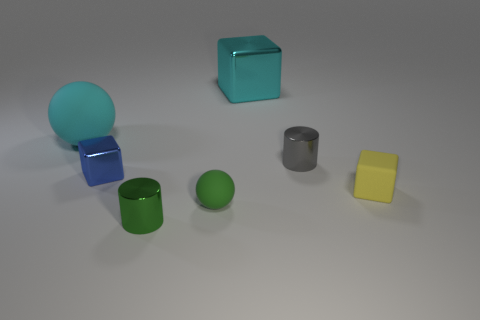There is a metallic cube that is the same color as the big ball; what is its size?
Ensure brevity in your answer.  Large. Is there a ball made of the same material as the yellow cube?
Provide a succinct answer. Yes. What shape is the tiny metal object that is both behind the green matte object and to the right of the small blue metal cube?
Offer a terse response. Cylinder. How many other things are the same shape as the big matte thing?
Keep it short and to the point. 1. The cyan matte ball has what size?
Your response must be concise. Large. How many objects are tiny red metal things or tiny blue shiny blocks?
Provide a succinct answer. 1. There is a cylinder that is on the right side of the cyan shiny thing; what size is it?
Give a very brief answer. Small. The rubber object that is behind the tiny green rubber thing and on the right side of the cyan matte ball is what color?
Your answer should be very brief. Yellow. Do the small object on the right side of the gray metal thing and the small green cylinder have the same material?
Offer a very short reply. No. There is a small ball; is its color the same as the small rubber object behind the green sphere?
Offer a terse response. No. 